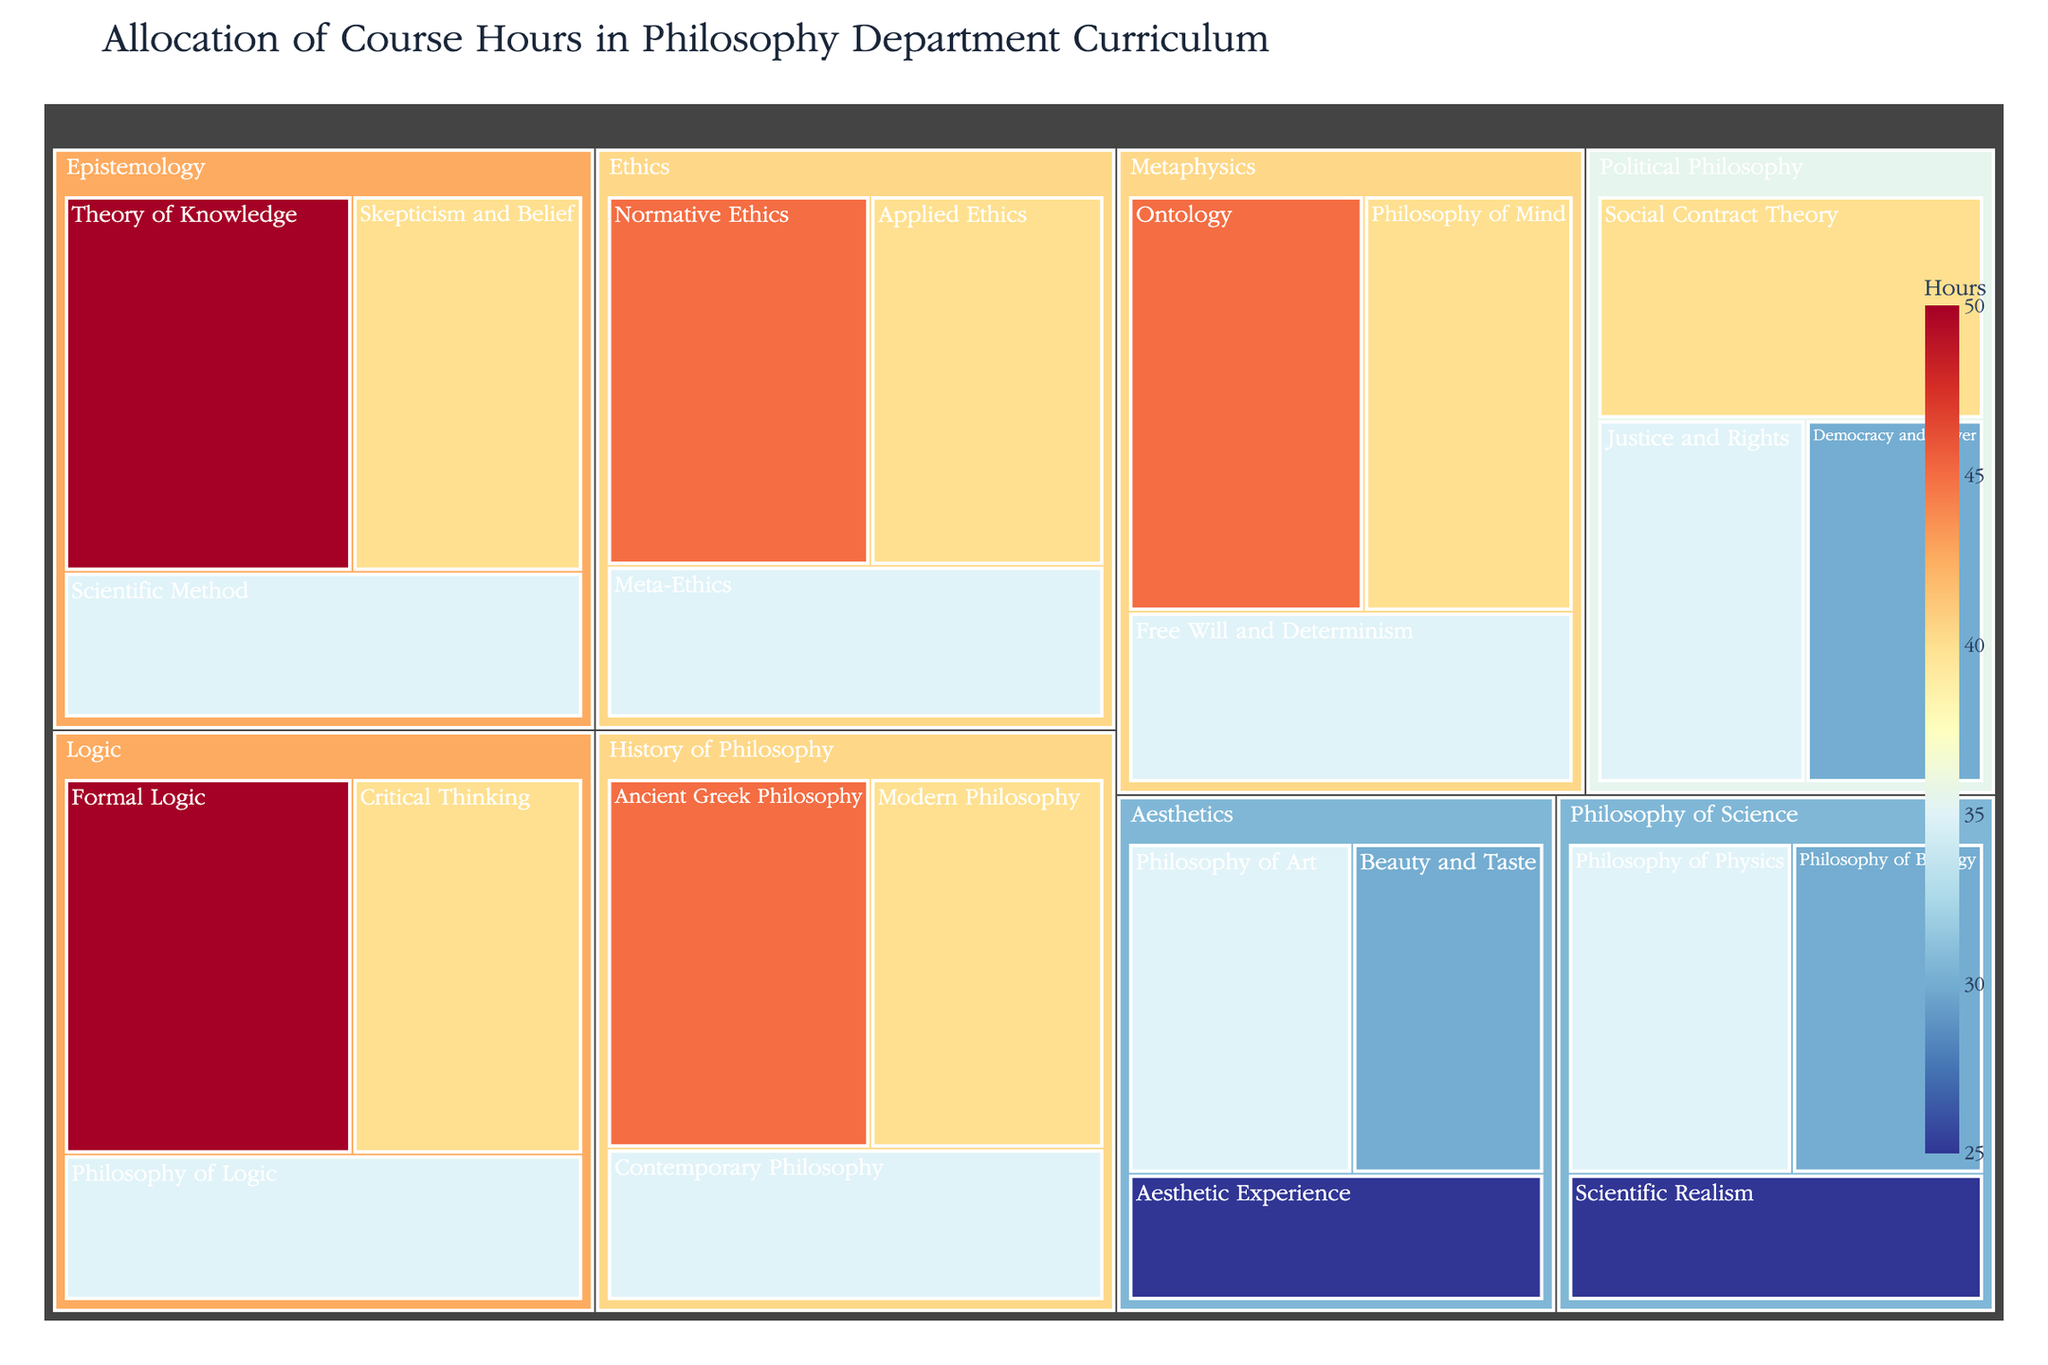What is the course with the most allocated hours in the Epistemology subfield? By examining the Epistemology subfield in the treemap, we see "Theory of Knowledge" has the largest area. Hence, it has the most allocated hours.
Answer: Theory of Knowledge How many total hours are allocated to the Logic subfield? Within the Logic subfield, the courses are "Formal Logic" (50 hours), "Critical Thinking" (40 hours), and "Philosophy of Logic" (35 hours). Summing these gives 50 + 40 + 35 = 125 hours.
Answer: 125 hours Which subfield has the smallest total allocation of course hours? By summing the hours for each subfield and comparing, the subfield with the smallest total is Aesthetics with 35 + 30 + 25 = 90 hours.
Answer: Aesthetics How many more hours are dedicated to "Ontology" compared to "Aesthetic Experience"? "Ontology" in Metaphysics has 45 hours while "Aesthetic Experience" in Aesthetics has 25 hours. The difference is 45 - 25 = 20 hours.
Answer: 20 hours What is the average number of hours allocated per course across all subfields? Summing all course hours: 45+40+35+50+40+35+45+40+35+50+40+35+40+35+30+35+30+25+35+30+25+45+40+35 = 750 hours. There are 23 courses: 750/23 ≈ 32.61 hours per course.
Answer: 32.61 hours Which course in the Ethics subfield has the fewest hours? Within the Ethics subfield, "Meta-Ethics" has 35 hours, which is fewer than both "Normative Ethics" (45 hours) and "Applied Ethics" (40 hours).
Answer: Meta-Ethics How does the allocation of hours to "Scientific Method" in the Epistemology subfield compare to "Philosophy of Physics" in the Philosophy of Science subfield? "Scientific Method" has 35 hours, while "Philosophy of Physics" also has 35 hours. They have equal allocation.
Answer: Equal What is the total number of hours allocated to the courses in the Metaphysics and Political Philosophy subfields combined? The Metaphysics subfield has courses with 45 + 40 + 35 = 120 hours, and the Political Philosophy subfield has 40 + 35 + 30 = 105 hours. Combined, this equals 120 + 105 = 225 hours.
Answer: 225 hours 